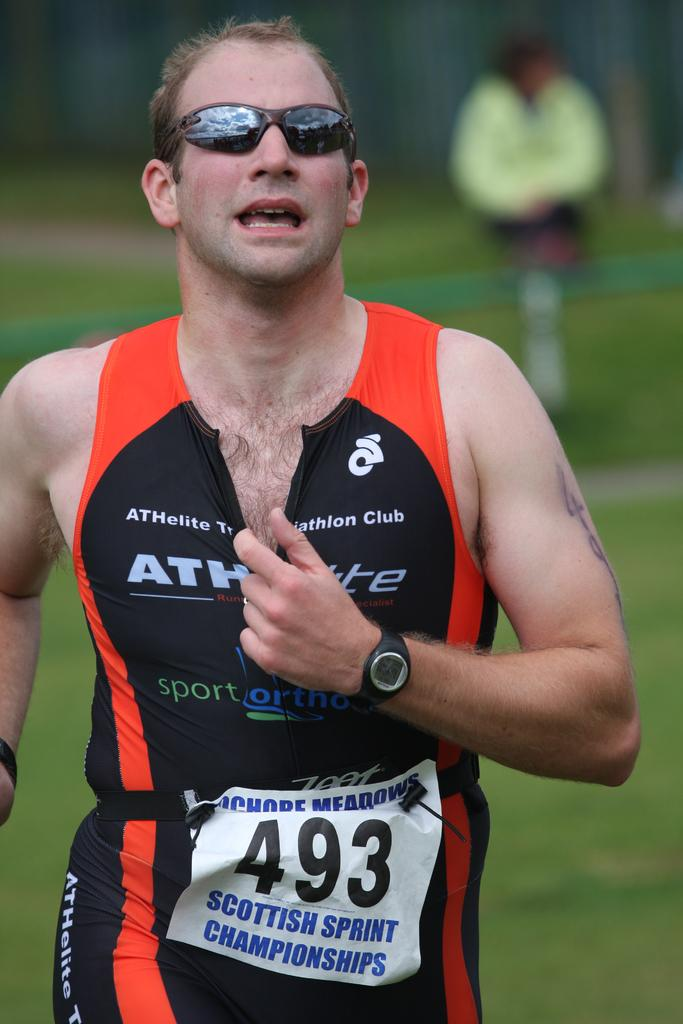<image>
Give a short and clear explanation of the subsequent image. A runner wears number 493 as he competes in the Scottish Sprint Championships. 